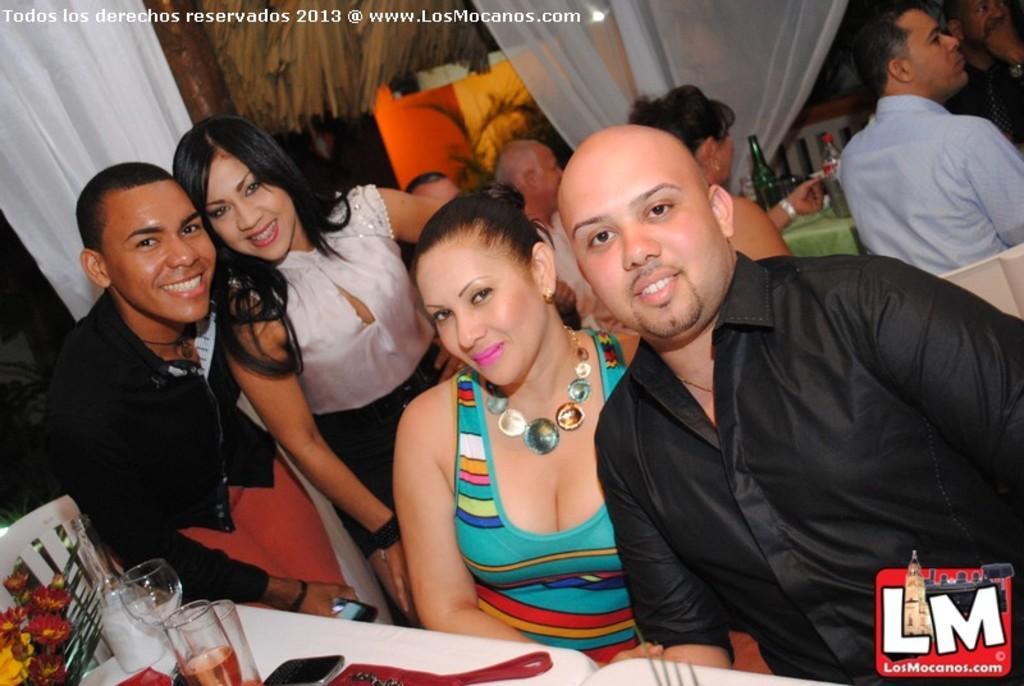Could you give a brief overview of what you see in this image? In this image I can see the group of people with different color dresses. I can see few people are sitting in-front of the tables. On the tables I can see the bottles, glasses, flowers and some objects. In the background I can see the plant and the white color curtains. 